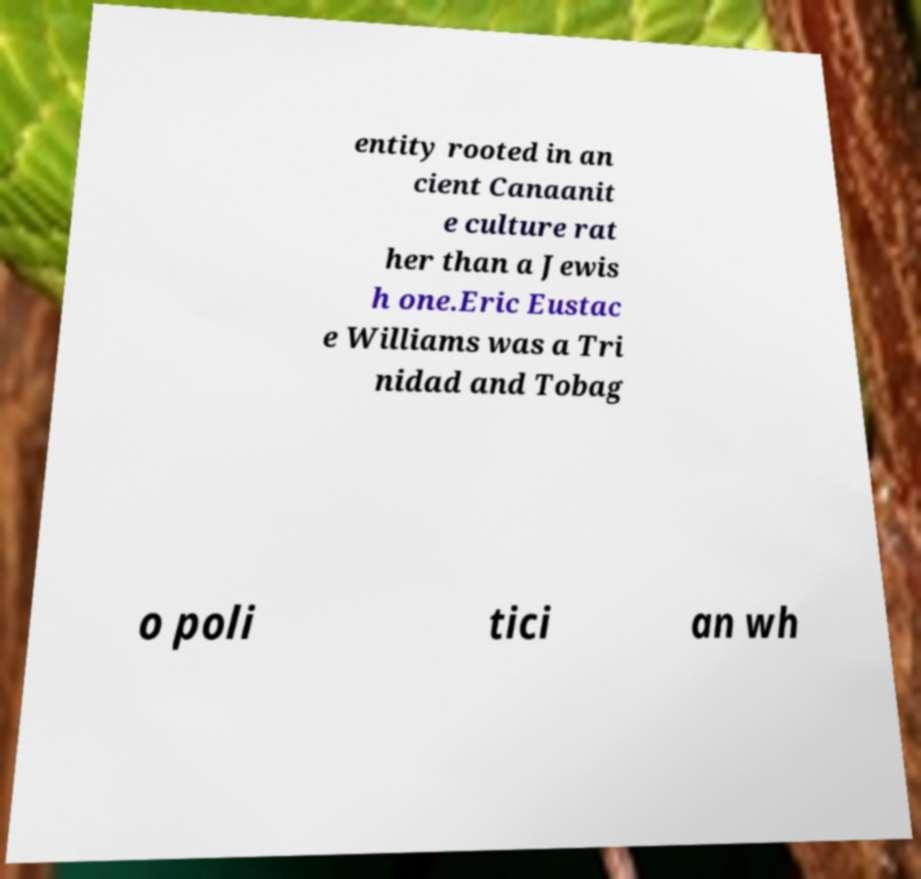Please identify and transcribe the text found in this image. entity rooted in an cient Canaanit e culture rat her than a Jewis h one.Eric Eustac e Williams was a Tri nidad and Tobag o poli tici an wh 